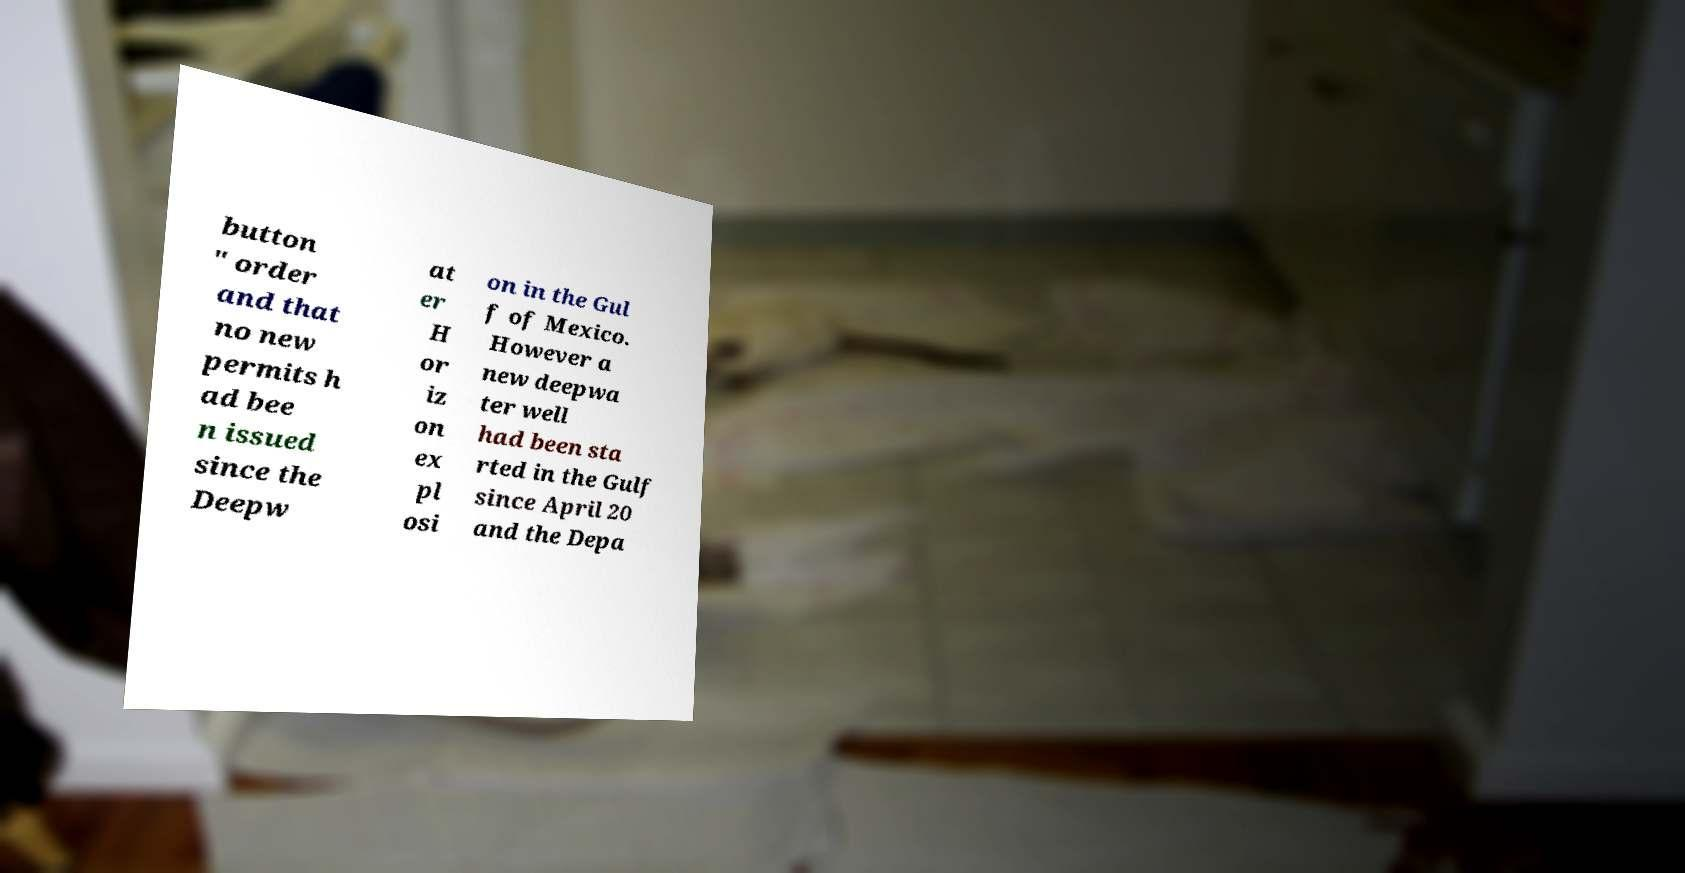For documentation purposes, I need the text within this image transcribed. Could you provide that? button " order and that no new permits h ad bee n issued since the Deepw at er H or iz on ex pl osi on in the Gul f of Mexico. However a new deepwa ter well had been sta rted in the Gulf since April 20 and the Depa 